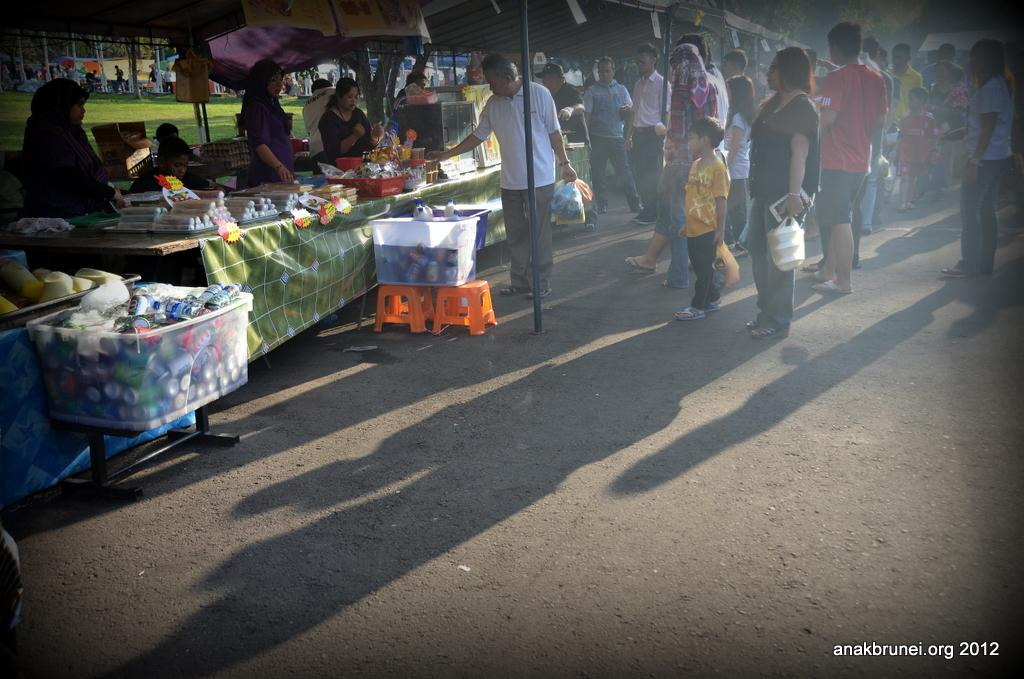What can be seen in the image involving a gathering of individuals? There is a group of people in the image. What type of structures are present in the image? There are stalls in the image. What is placed on a table in the image? There are objects on a table in the image. How are the bottles arranged in the image? There are bottles in a basket in the image. What type of song is being sung by the people in the image? There is no indication in the image that the people are singing a song. Can you describe the grapes that are being served in the image? There is no mention of grapes in the image; it features a group of people, stalls, objects on a table, and bottles in a basket. 